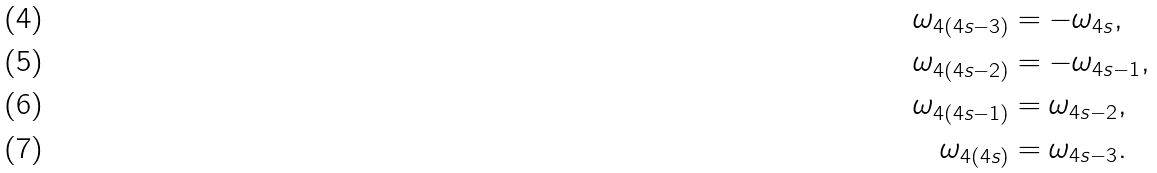<formula> <loc_0><loc_0><loc_500><loc_500>\omega _ { 4 ( 4 s - 3 ) } & = - \omega _ { 4 s } , \\ \omega _ { 4 ( 4 s - 2 ) } & = - \omega _ { 4 s - 1 } , \\ \omega _ { 4 ( 4 s - 1 ) } & = \omega _ { 4 s - 2 } , \\ \omega _ { 4 ( 4 s ) } & = \omega _ { 4 s - 3 } .</formula> 